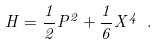Convert formula to latex. <formula><loc_0><loc_0><loc_500><loc_500>H = \frac { 1 } { 2 } P ^ { 2 } + \frac { 1 } { 6 } X ^ { 4 } \ .</formula> 